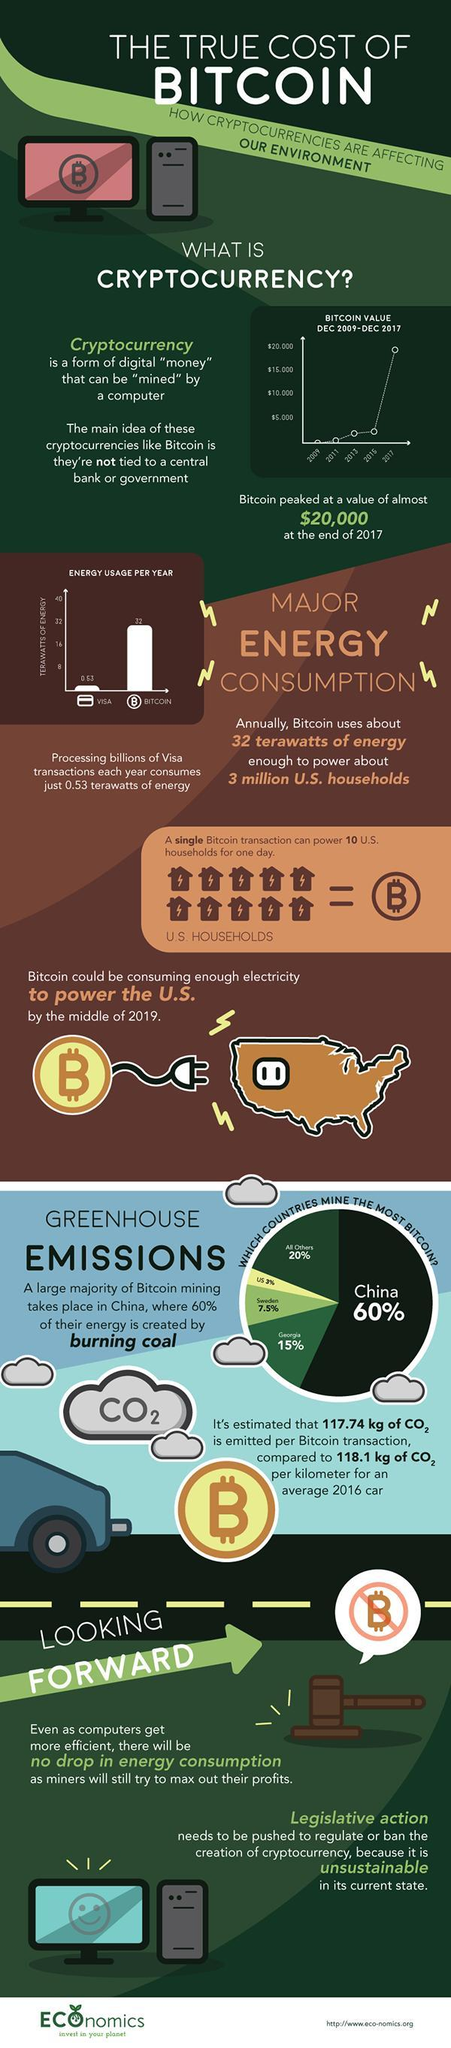Which form of transaction consumes less energy?
Answer the question with a short phrase. Visa After China who mines the most bitcoins? Georgia In which year was the value of bitcoin lowest? 2009 